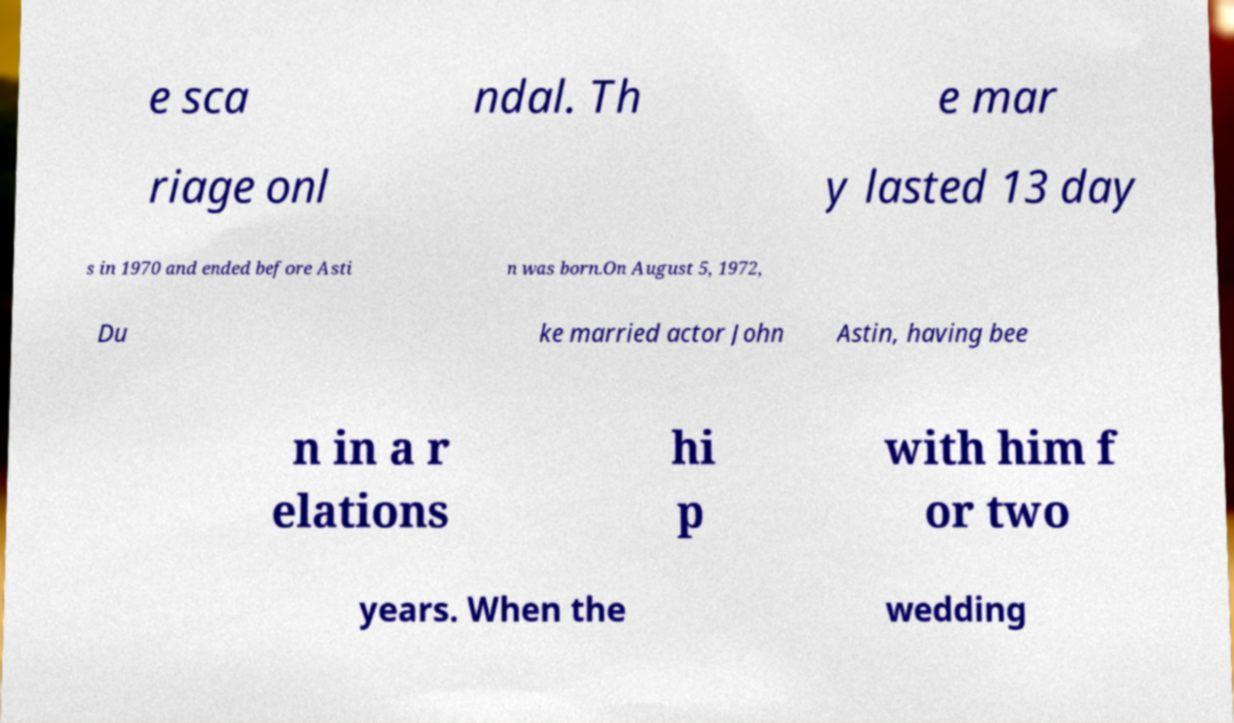There's text embedded in this image that I need extracted. Can you transcribe it verbatim? e sca ndal. Th e mar riage onl y lasted 13 day s in 1970 and ended before Asti n was born.On August 5, 1972, Du ke married actor John Astin, having bee n in a r elations hi p with him f or two years. When the wedding 